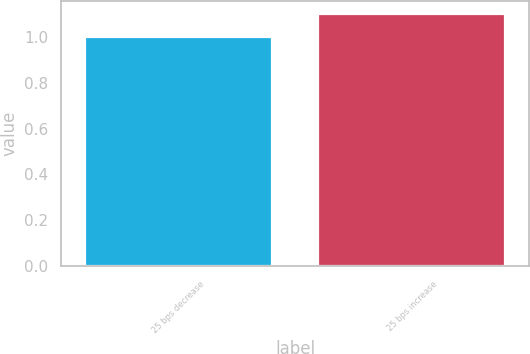<chart> <loc_0><loc_0><loc_500><loc_500><bar_chart><fcel>25 bps decrease<fcel>25 bps increase<nl><fcel>1<fcel>1.1<nl></chart> 